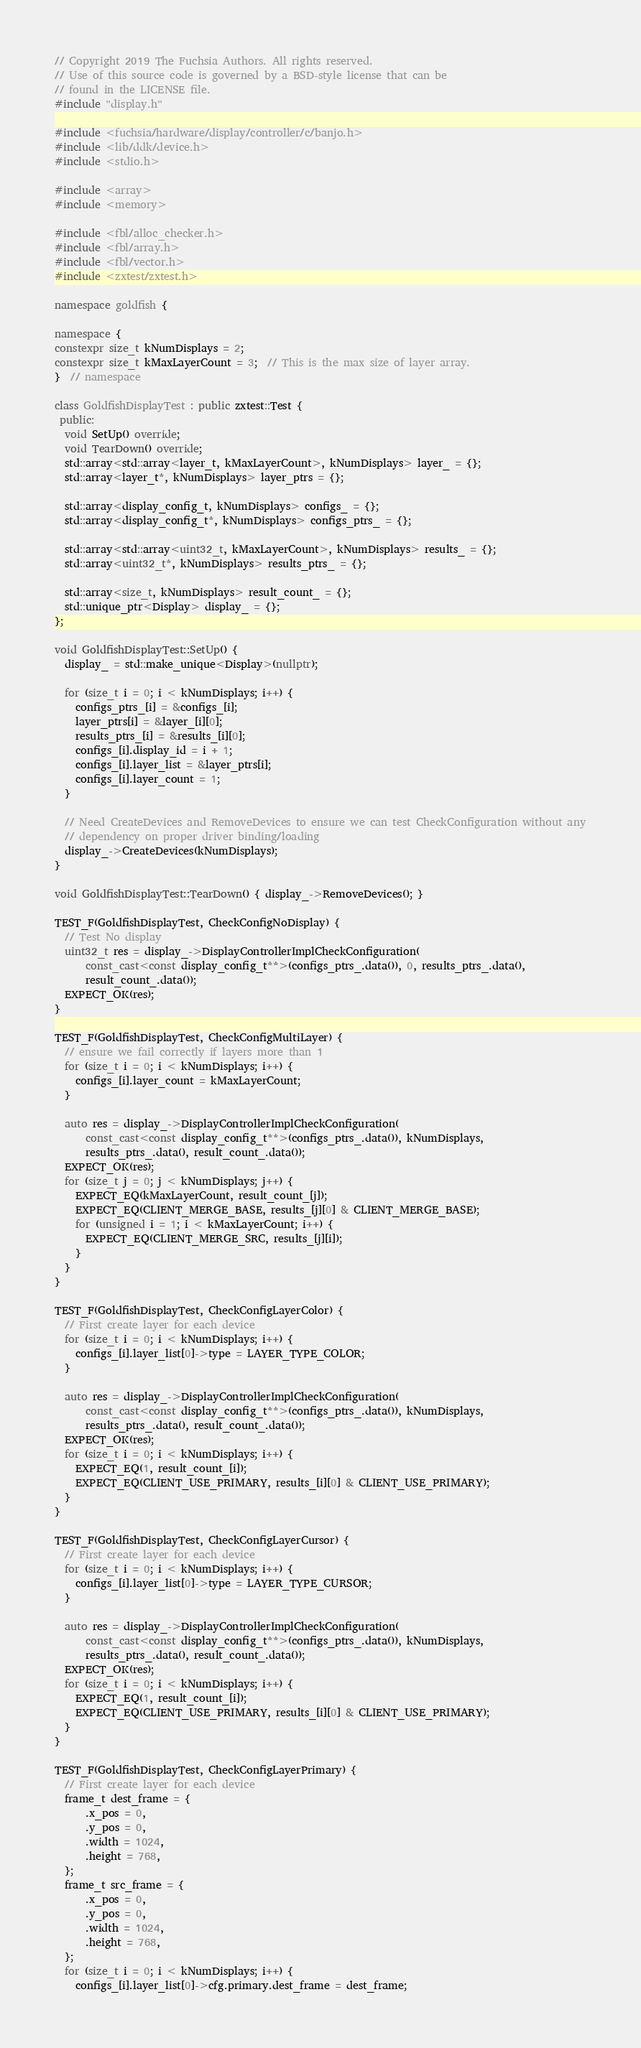Convert code to text. <code><loc_0><loc_0><loc_500><loc_500><_C++_>// Copyright 2019 The Fuchsia Authors. All rights reserved.
// Use of this source code is governed by a BSD-style license that can be
// found in the LICENSE file.
#include "display.h"

#include <fuchsia/hardware/display/controller/c/banjo.h>
#include <lib/ddk/device.h>
#include <stdio.h>

#include <array>
#include <memory>

#include <fbl/alloc_checker.h>
#include <fbl/array.h>
#include <fbl/vector.h>
#include <zxtest/zxtest.h>

namespace goldfish {

namespace {
constexpr size_t kNumDisplays = 2;
constexpr size_t kMaxLayerCount = 3;  // This is the max size of layer array.
}  // namespace

class GoldfishDisplayTest : public zxtest::Test {
 public:
  void SetUp() override;
  void TearDown() override;
  std::array<std::array<layer_t, kMaxLayerCount>, kNumDisplays> layer_ = {};
  std::array<layer_t*, kNumDisplays> layer_ptrs = {};

  std::array<display_config_t, kNumDisplays> configs_ = {};
  std::array<display_config_t*, kNumDisplays> configs_ptrs_ = {};

  std::array<std::array<uint32_t, kMaxLayerCount>, kNumDisplays> results_ = {};
  std::array<uint32_t*, kNumDisplays> results_ptrs_ = {};

  std::array<size_t, kNumDisplays> result_count_ = {};
  std::unique_ptr<Display> display_ = {};
};

void GoldfishDisplayTest::SetUp() {
  display_ = std::make_unique<Display>(nullptr);

  for (size_t i = 0; i < kNumDisplays; i++) {
    configs_ptrs_[i] = &configs_[i];
    layer_ptrs[i] = &layer_[i][0];
    results_ptrs_[i] = &results_[i][0];
    configs_[i].display_id = i + 1;
    configs_[i].layer_list = &layer_ptrs[i];
    configs_[i].layer_count = 1;
  }

  // Need CreateDevices and RemoveDevices to ensure we can test CheckConfiguration without any
  // dependency on proper driver binding/loading
  display_->CreateDevices(kNumDisplays);
}

void GoldfishDisplayTest::TearDown() { display_->RemoveDevices(); }

TEST_F(GoldfishDisplayTest, CheckConfigNoDisplay) {
  // Test No display
  uint32_t res = display_->DisplayControllerImplCheckConfiguration(
      const_cast<const display_config_t**>(configs_ptrs_.data()), 0, results_ptrs_.data(),
      result_count_.data());
  EXPECT_OK(res);
}

TEST_F(GoldfishDisplayTest, CheckConfigMultiLayer) {
  // ensure we fail correctly if layers more than 1
  for (size_t i = 0; i < kNumDisplays; i++) {
    configs_[i].layer_count = kMaxLayerCount;
  }

  auto res = display_->DisplayControllerImplCheckConfiguration(
      const_cast<const display_config_t**>(configs_ptrs_.data()), kNumDisplays,
      results_ptrs_.data(), result_count_.data());
  EXPECT_OK(res);
  for (size_t j = 0; j < kNumDisplays; j++) {
    EXPECT_EQ(kMaxLayerCount, result_count_[j]);
    EXPECT_EQ(CLIENT_MERGE_BASE, results_[j][0] & CLIENT_MERGE_BASE);
    for (unsigned i = 1; i < kMaxLayerCount; i++) {
      EXPECT_EQ(CLIENT_MERGE_SRC, results_[j][i]);
    }
  }
}

TEST_F(GoldfishDisplayTest, CheckConfigLayerColor) {
  // First create layer for each device
  for (size_t i = 0; i < kNumDisplays; i++) {
    configs_[i].layer_list[0]->type = LAYER_TYPE_COLOR;
  }

  auto res = display_->DisplayControllerImplCheckConfiguration(
      const_cast<const display_config_t**>(configs_ptrs_.data()), kNumDisplays,
      results_ptrs_.data(), result_count_.data());
  EXPECT_OK(res);
  for (size_t i = 0; i < kNumDisplays; i++) {
    EXPECT_EQ(1, result_count_[i]);
    EXPECT_EQ(CLIENT_USE_PRIMARY, results_[i][0] & CLIENT_USE_PRIMARY);
  }
}

TEST_F(GoldfishDisplayTest, CheckConfigLayerCursor) {
  // First create layer for each device
  for (size_t i = 0; i < kNumDisplays; i++) {
    configs_[i].layer_list[0]->type = LAYER_TYPE_CURSOR;
  }

  auto res = display_->DisplayControllerImplCheckConfiguration(
      const_cast<const display_config_t**>(configs_ptrs_.data()), kNumDisplays,
      results_ptrs_.data(), result_count_.data());
  EXPECT_OK(res);
  for (size_t i = 0; i < kNumDisplays; i++) {
    EXPECT_EQ(1, result_count_[i]);
    EXPECT_EQ(CLIENT_USE_PRIMARY, results_[i][0] & CLIENT_USE_PRIMARY);
  }
}

TEST_F(GoldfishDisplayTest, CheckConfigLayerPrimary) {
  // First create layer for each device
  frame_t dest_frame = {
      .x_pos = 0,
      .y_pos = 0,
      .width = 1024,
      .height = 768,
  };
  frame_t src_frame = {
      .x_pos = 0,
      .y_pos = 0,
      .width = 1024,
      .height = 768,
  };
  for (size_t i = 0; i < kNumDisplays; i++) {
    configs_[i].layer_list[0]->cfg.primary.dest_frame = dest_frame;</code> 